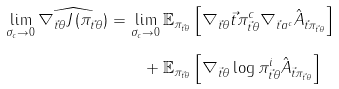<formula> <loc_0><loc_0><loc_500><loc_500>\lim _ { \sigma _ { c } \rightarrow 0 } \widehat { \nabla _ { \vec { t } \theta } J \left ( \pi _ { \vec { t } \theta } \right ) } = & \, \lim _ { \sigma _ { c } \rightarrow 0 } \mathbb { E } _ { \pi _ { \vec { t } \theta } } \left [ \nabla _ { \vec { t } \theta } \vec { t } \pi ^ { c } _ { \vec { t } \theta } \nabla _ { \vec { t } a ^ { c } } \hat { A } _ { \vec { t } \pi _ { \vec { t } \theta } } \right ] \\ & \quad + \mathbb { E } _ { \pi _ { \vec { t } \theta } } \left [ \nabla _ { \vec { t } \theta } \log \pi ^ { i } _ { \vec { t } \theta } \hat { A } _ { \vec { t } \pi _ { \vec { t } \theta } } \right ]</formula> 